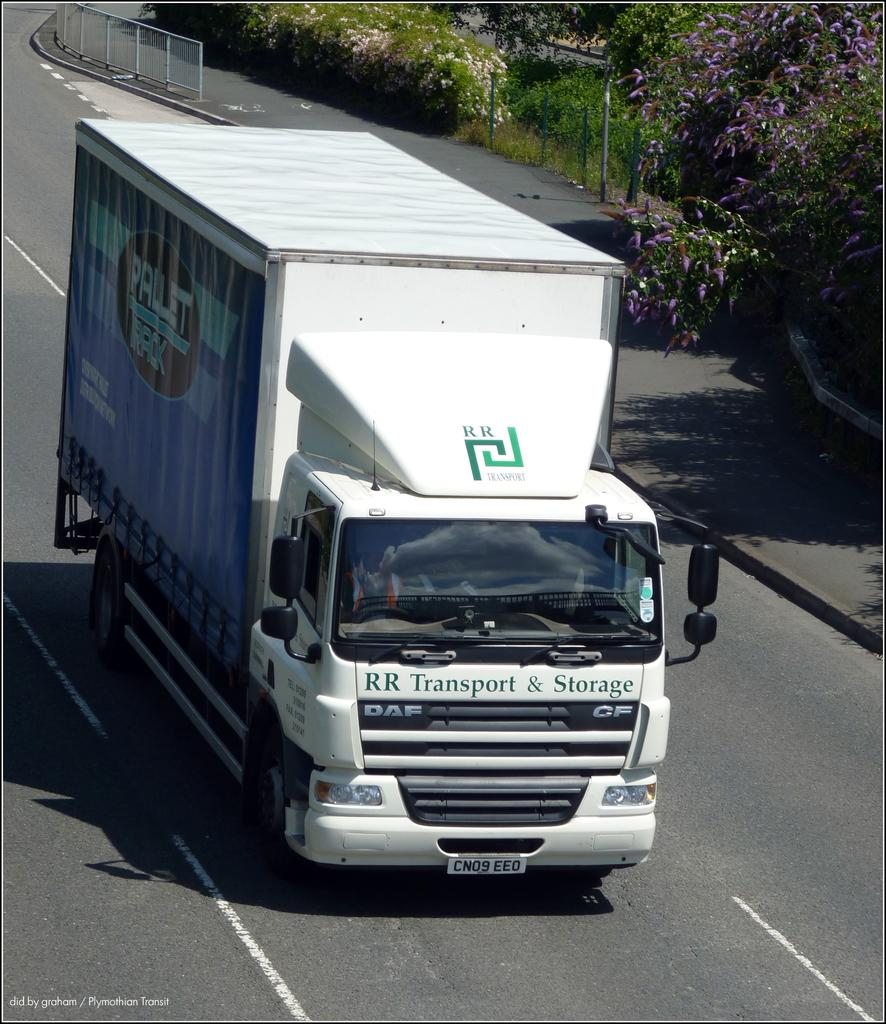What is the main subject in the center of the image? There is a truck in the center of the image. What type of vegetation can be seen in the image? There are flower trees in the image. What can be seen at the top side of the image? There is a boundary at the top side of the image. What is the answer to the riddle in the image? There is no riddle present in the image. --- Facts: 1. There is a person in the image. 2. The person is wearing a hat. 3. The person is holding a book. 4. The background of the image is a library. Absurd Topics: magic Conversation: Who or what is the main subject in the image? There is a person in the image. What is the person wearing in the image? The person is wearing a hat. What is the person holding in the image? The person is holding a book. What is the background of the image? The background of the image is a library. Reasoning: Let's think step by step in order to produce the conversation. We start by identifying the main subject in the image, which is a person. Then, we describe the person's attire, mentioning that they are wearing a hat. Next, we observe what the person is holding, which is a book. Finally, we describe the background of the image, which is a library. Absurd Question/Answer: What type of magic is being performed by the person in the image? There is no indication of magic being performed by the person in the image. 